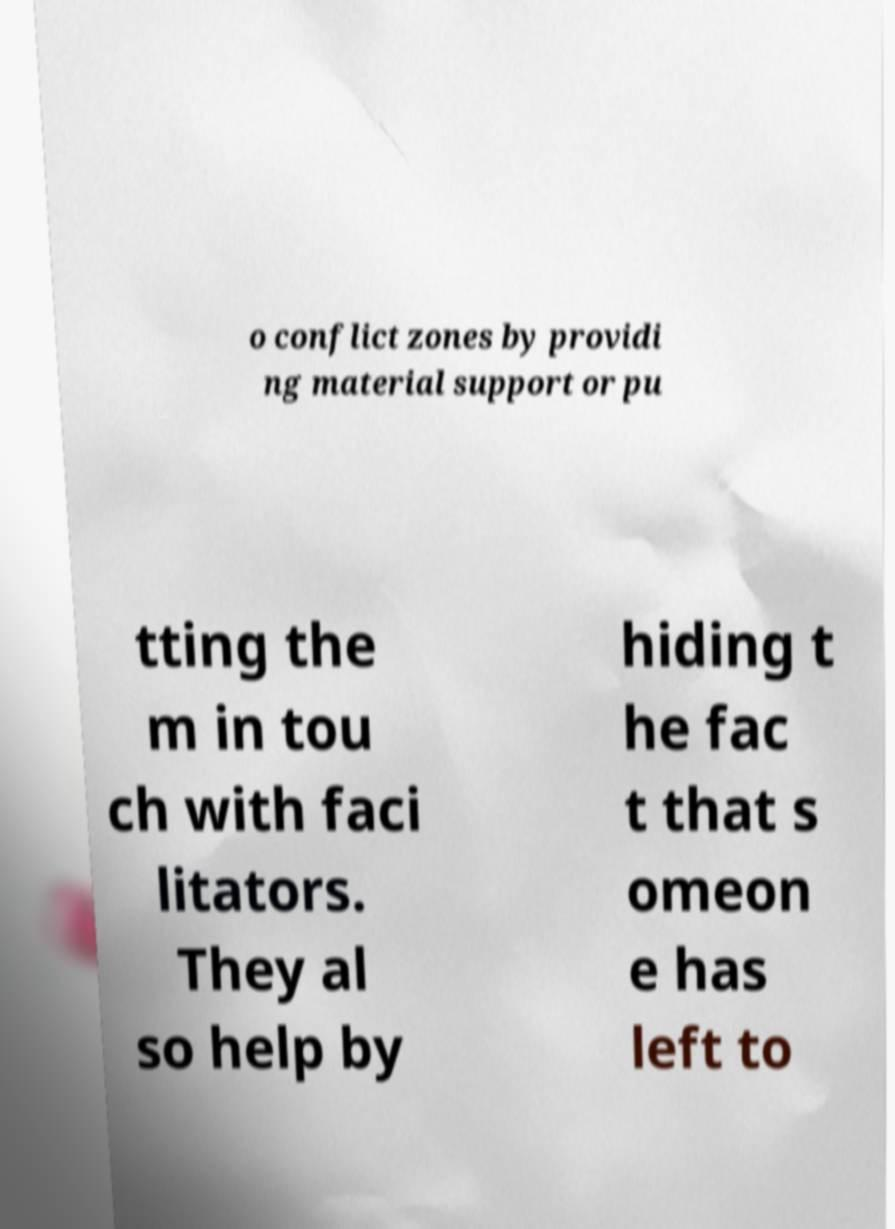Please identify and transcribe the text found in this image. o conflict zones by providi ng material support or pu tting the m in tou ch with faci litators. They al so help by hiding t he fac t that s omeon e has left to 